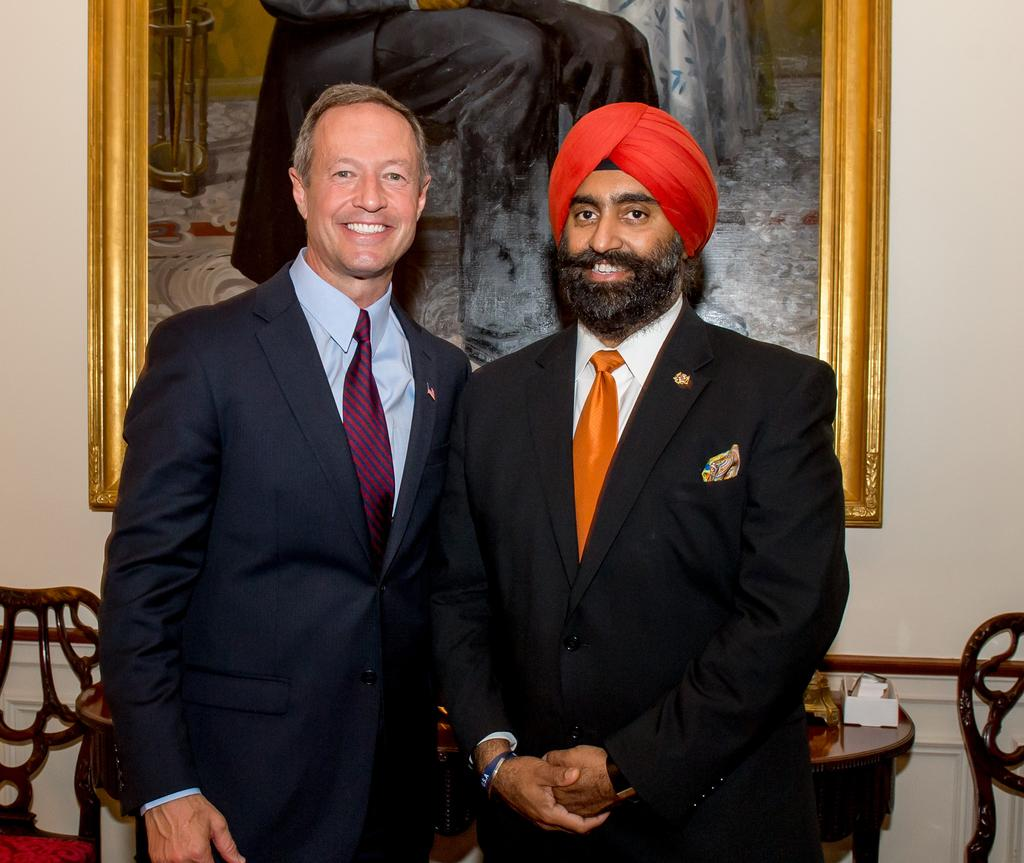How many people are in the image? There are two men standing in the image. What type of furniture is present in the image? There are chairs in the image. What is on the table in the image? There is a table with objects on it in the image. What can be seen in the photo frame on the wall? There is a photo frame with a picture of a person on a wall in the image. What is the name of the person in the wind in the image? There is no person in the wind in the image, and no names are mentioned. 